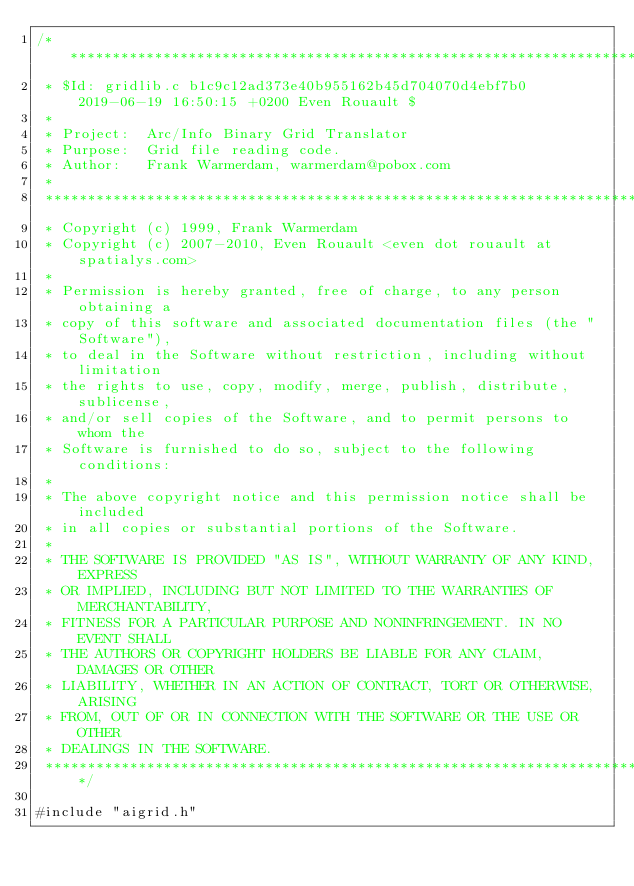<code> <loc_0><loc_0><loc_500><loc_500><_C_>/******************************************************************************
 * $Id: gridlib.c b1c9c12ad373e40b955162b45d704070d4ebf7b0 2019-06-19 16:50:15 +0200 Even Rouault $
 *
 * Project:  Arc/Info Binary Grid Translator
 * Purpose:  Grid file reading code.
 * Author:   Frank Warmerdam, warmerdam@pobox.com
 *
 ******************************************************************************
 * Copyright (c) 1999, Frank Warmerdam
 * Copyright (c) 2007-2010, Even Rouault <even dot rouault at spatialys.com>
 *
 * Permission is hereby granted, free of charge, to any person obtaining a
 * copy of this software and associated documentation files (the "Software"),
 * to deal in the Software without restriction, including without limitation
 * the rights to use, copy, modify, merge, publish, distribute, sublicense,
 * and/or sell copies of the Software, and to permit persons to whom the
 * Software is furnished to do so, subject to the following conditions:
 *
 * The above copyright notice and this permission notice shall be included
 * in all copies or substantial portions of the Software.
 *
 * THE SOFTWARE IS PROVIDED "AS IS", WITHOUT WARRANTY OF ANY KIND, EXPRESS
 * OR IMPLIED, INCLUDING BUT NOT LIMITED TO THE WARRANTIES OF MERCHANTABILITY,
 * FITNESS FOR A PARTICULAR PURPOSE AND NONINFRINGEMENT. IN NO EVENT SHALL
 * THE AUTHORS OR COPYRIGHT HOLDERS BE LIABLE FOR ANY CLAIM, DAMAGES OR OTHER
 * LIABILITY, WHETHER IN AN ACTION OF CONTRACT, TORT OR OTHERWISE, ARISING
 * FROM, OUT OF OR IN CONNECTION WITH THE SOFTWARE OR THE USE OR OTHER
 * DEALINGS IN THE SOFTWARE.
 ****************************************************************************/

#include "aigrid.h"
</code> 